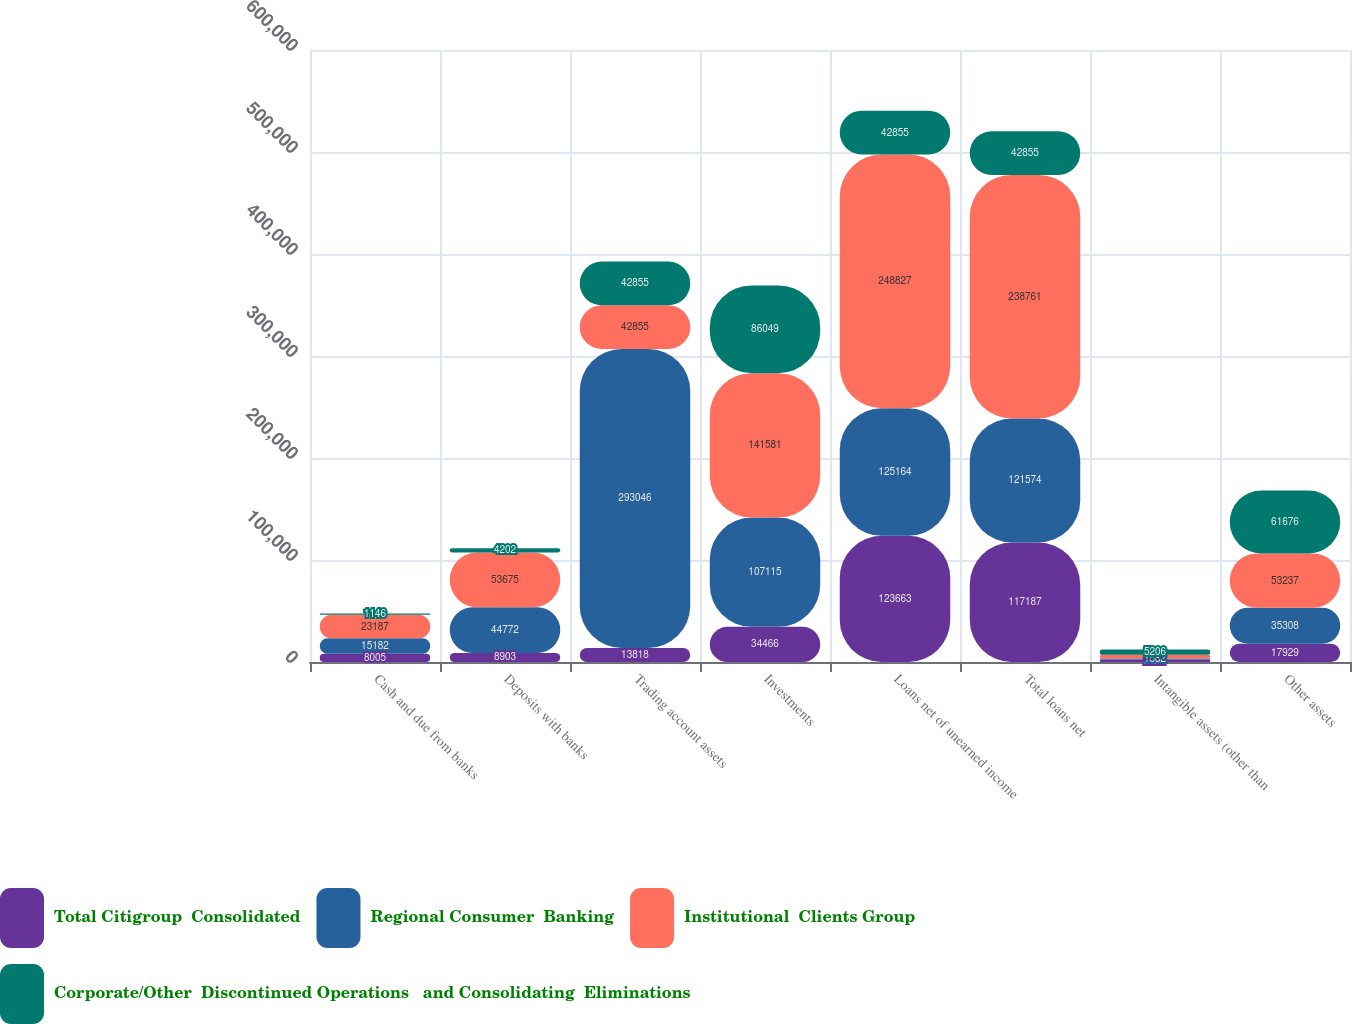Convert chart to OTSL. <chart><loc_0><loc_0><loc_500><loc_500><stacked_bar_chart><ecel><fcel>Cash and due from banks<fcel>Deposits with banks<fcel>Trading account assets<fcel>Investments<fcel>Loans net of unearned income<fcel>Total loans net<fcel>Intangible assets (other than<fcel>Other assets<nl><fcel>Total Citigroup  Consolidated<fcel>8005<fcel>8903<fcel>13818<fcel>34466<fcel>123663<fcel>117187<fcel>2424<fcel>17929<nl><fcel>Regional Consumer  Banking<fcel>15182<fcel>44772<fcel>293046<fcel>107115<fcel>125164<fcel>121574<fcel>1082<fcel>35308<nl><fcel>Institutional  Clients Group<fcel>23187<fcel>53675<fcel>42855<fcel>141581<fcel>248827<fcel>238761<fcel>3506<fcel>53237<nl><fcel>Corporate/Other  Discontinued Operations   and Consolidating  Eliminations<fcel>1146<fcel>4202<fcel>42855<fcel>86049<fcel>42855<fcel>42855<fcel>5206<fcel>61676<nl></chart> 